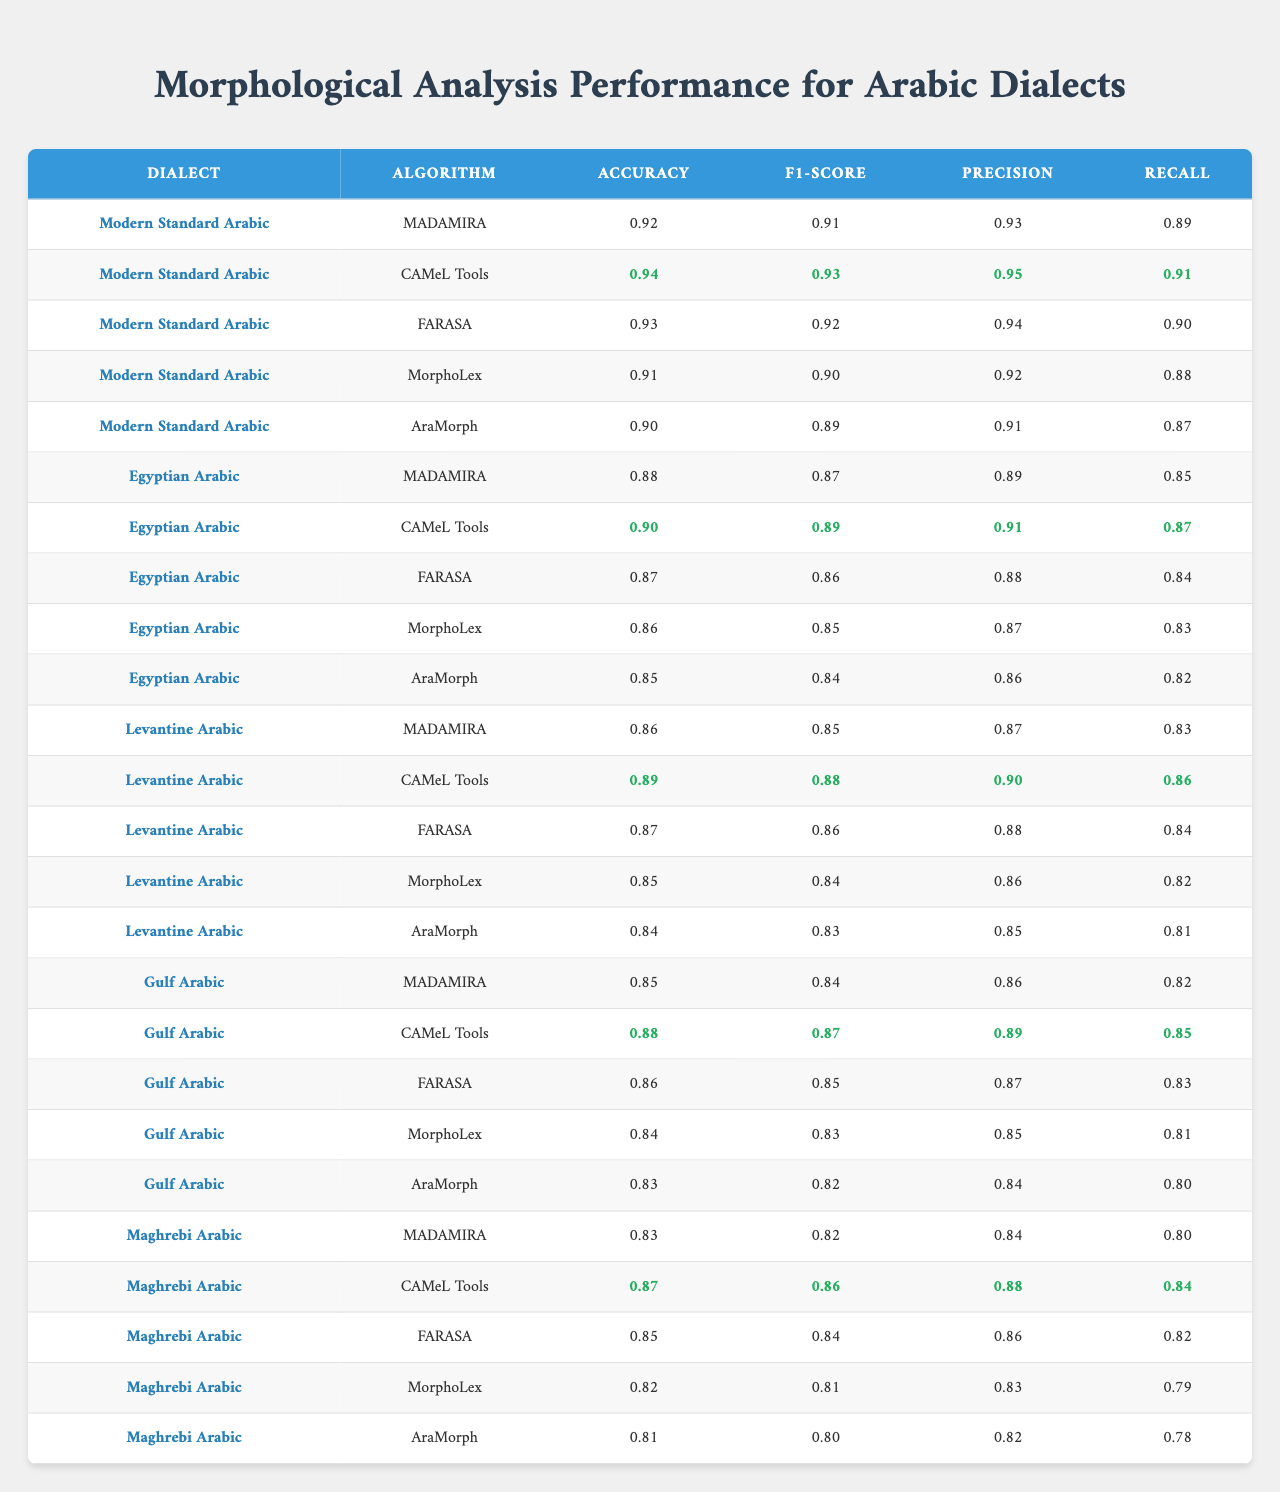What is the highest accuracy achieved for Modern Standard Arabic using CAMeL Tools? The table shows that the accuracy for Modern Standard Arabic using CAMeL Tools is 0.94, which is the highest accuracy among the algorithms for this dialect.
Answer: 0.94 Which algorithm has the lowest F1-score for Egyptian Arabic? According to the table, the lowest F1-score for Egyptian Arabic is 0.84, which belongs to AraMorph.
Answer: 0.84 Is the Precision of FARASA higher than the Precision of MorphoLex for Levantine Arabic? The table indicates that FARASA has a Precision of 0.88 and MorphoLex has a Precision of 0.86 for Levantine Arabic. Since 0.88 is greater than 0.86, the statement is true.
Answer: Yes What is the average Recall across all algorithms for Gulf Arabic? The Recall values for Gulf Arabic are 0.82 (MADAMIRA), 0.85 (CAMeL Tools), 0.83 (FARASA), 0.81 (MorphoLex), and 0.80 (AraMorph). Adding these gives 0.82 + 0.85 + 0.83 + 0.81 + 0.80 = 4.11, and dividing by 5 gives an average Recall of 4.11 / 5 = 0.822.
Answer: 0.82 Which dialect shows the best performance in terms of Precision across all algorithms? To determine the best Precision, we compare all the algorithm Precision scores for each dialect. The highest Precision is 0.95 for Modern Standard Arabic using CAMeL Tools, indicating it has the best performance.
Answer: Modern Standard Arabic Is it true that AraMorph performs consistently worse across all metrics for Maghrebi Arabic compared to other algorithms? Upon examining the table, AraMorph has the lowest scores in all metrics for Maghrebi Arabic: Accuracy (0.81), F1-score (0.80), Precision (0.82), and Recall (0.78), confirming the statement.
Answer: True What is the difference in Accuracy between FARASA and CAMeL Tools for Egyptian Arabic? The Accuracy for FARASA is 0.87 and for CAMeL Tools is 0.90. The difference is 0.90 - 0.87 = 0.03.
Answer: 0.03 What is the highest recall value in the table and which dialect/algorithm does it correspond to? The highest Recall value across all entries is 0.95, corresponding to Modern Standard Arabic with CAMeL Tools.
Answer: 0.95 (Modern Standard Arabic, CAMeL Tools) Which algorithm has the greatest variation in Precision across all dialects? By comparing the Precision values for each algorithm across all dialects, AraMorph has a range from 0.86 (Egyptian Arabic) to 0.82 (Maghrebi Arabic), which is a variation of 0.04. This variation is greater than that of other algorithms.
Answer: AraMorph 